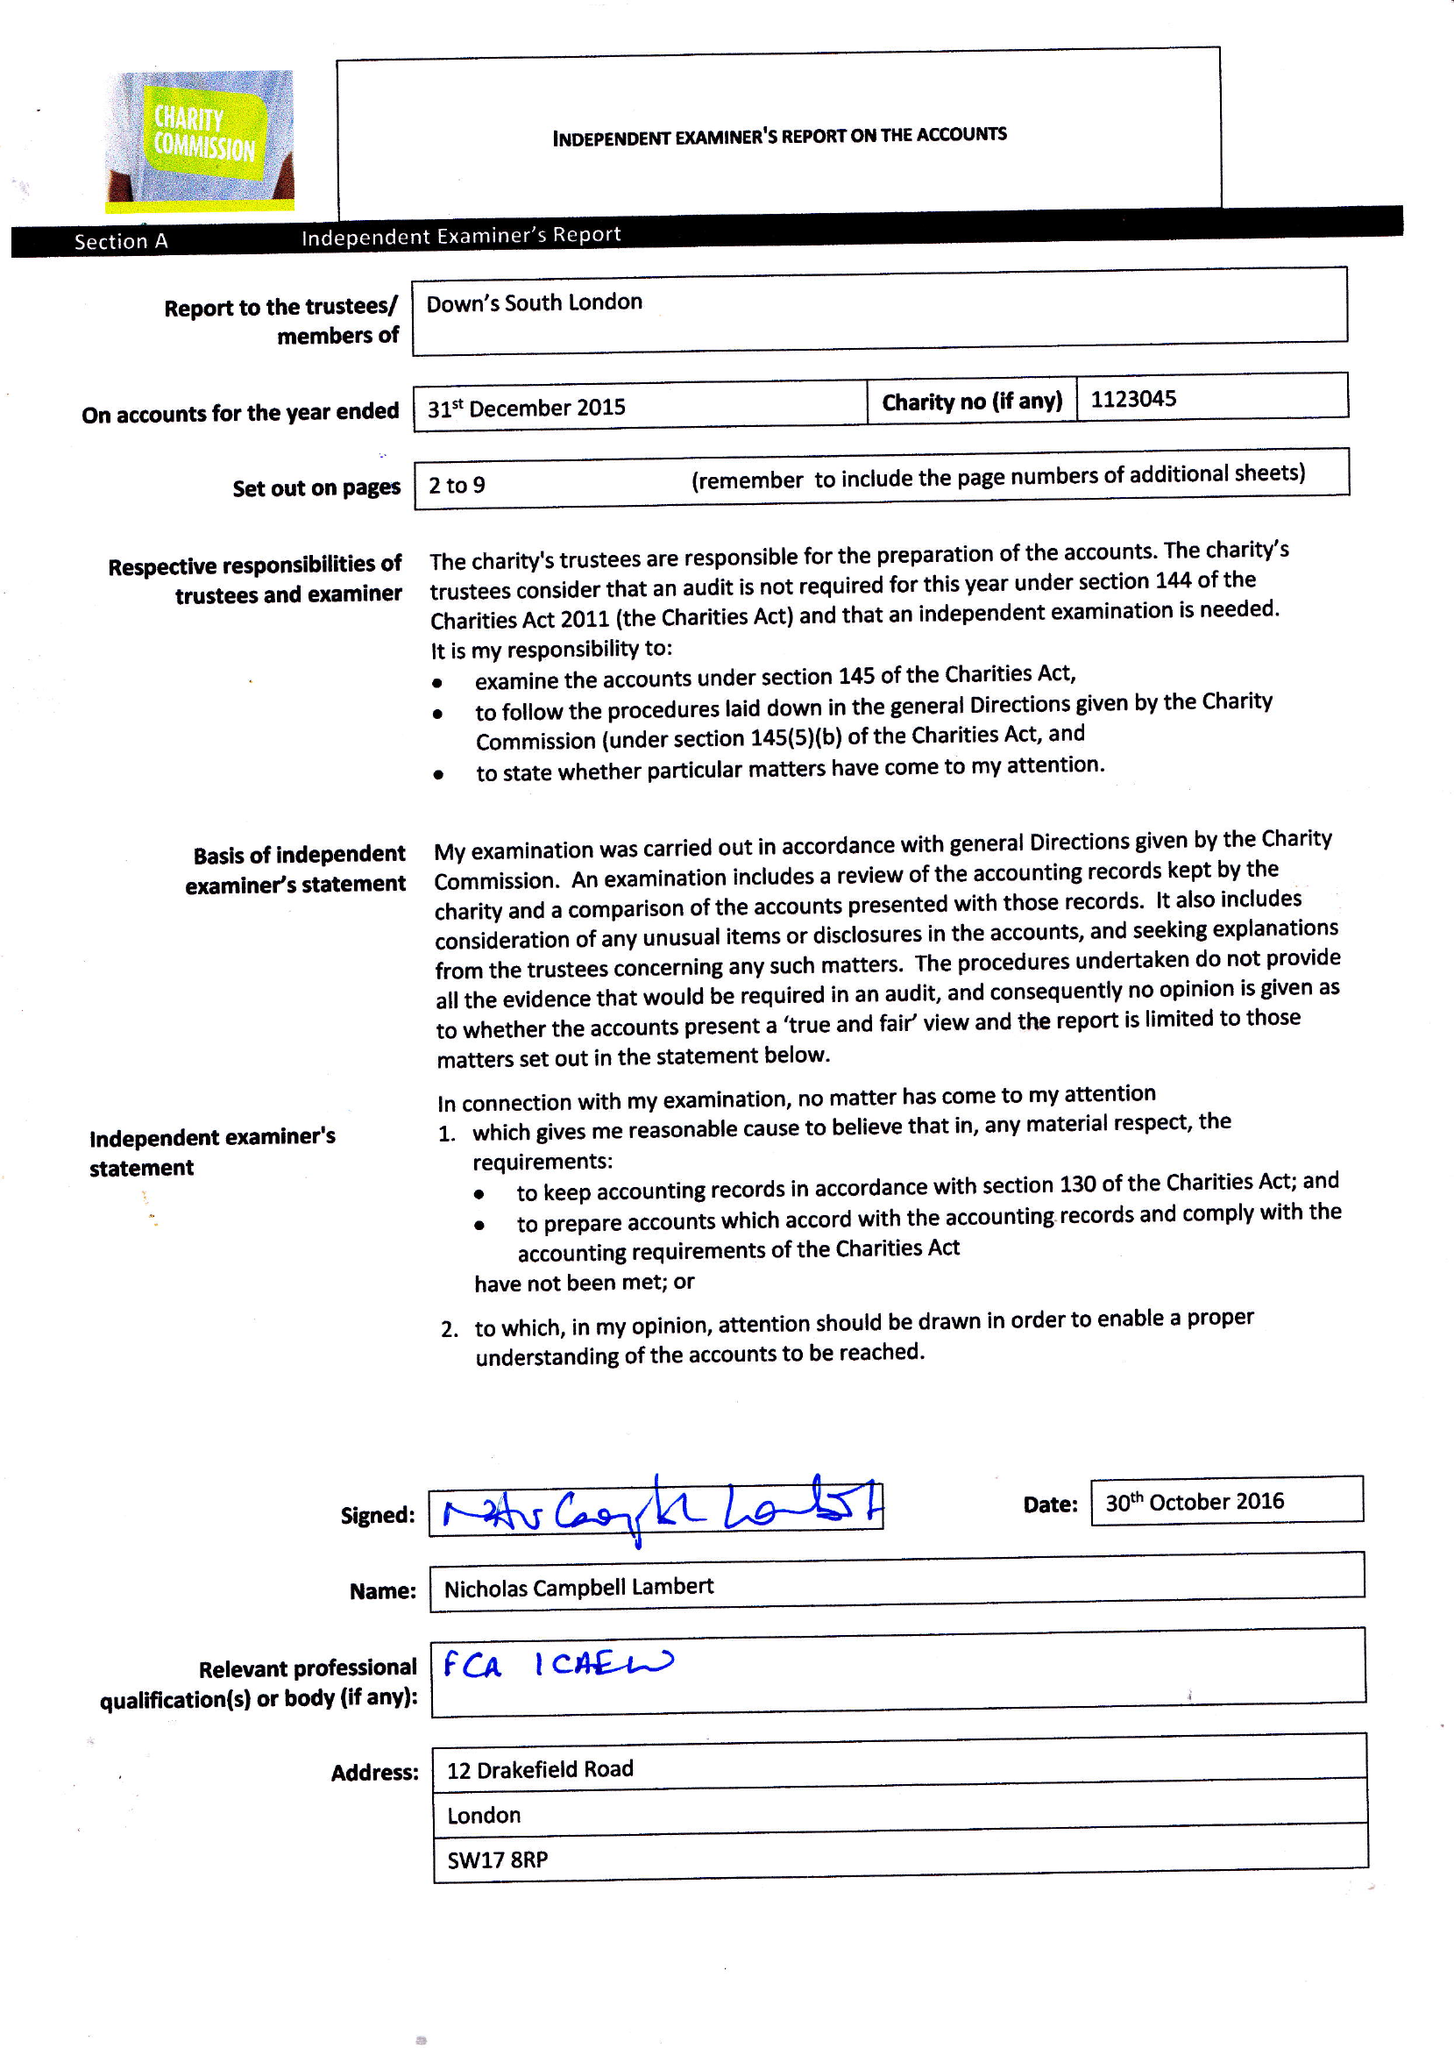What is the value for the address__street_line?
Answer the question using a single word or phrase. 59 LYNDHURST GROVE 